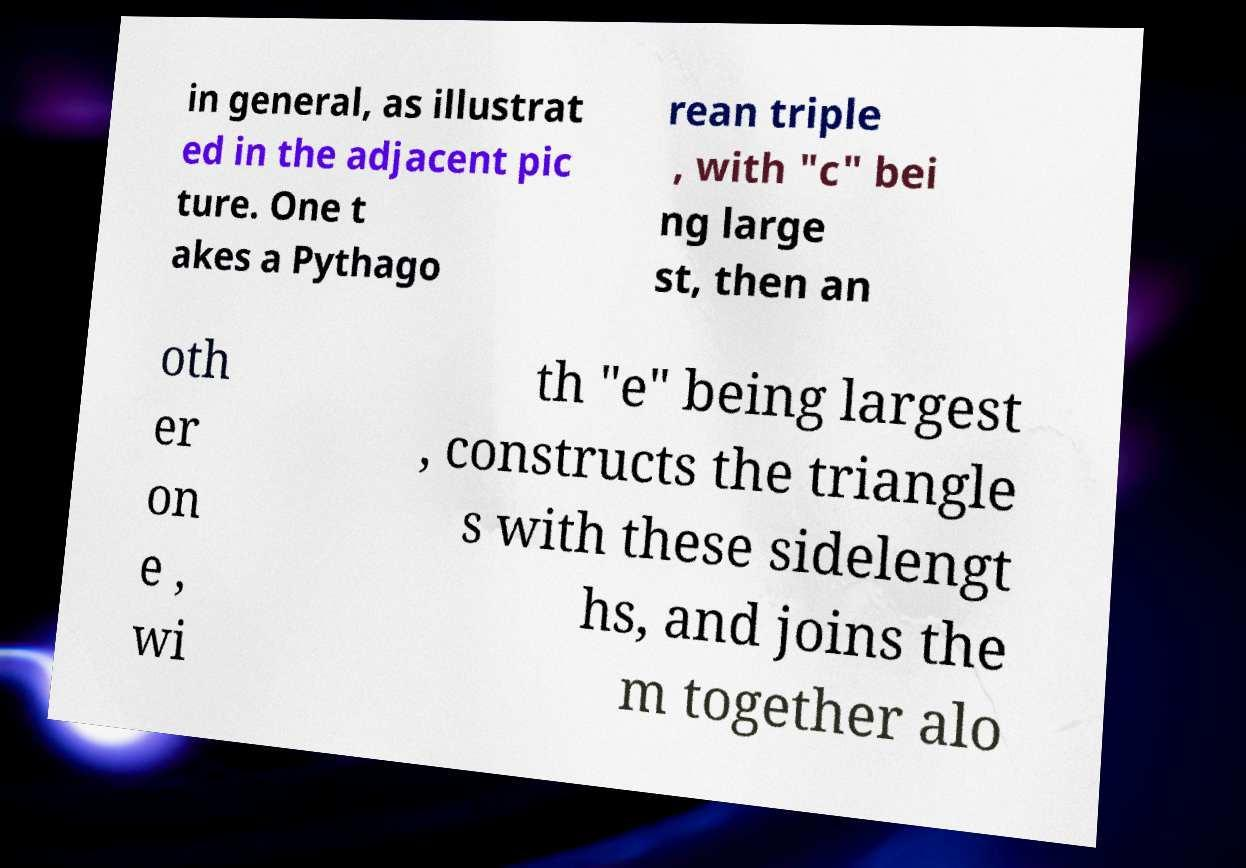What messages or text are displayed in this image? I need them in a readable, typed format. in general, as illustrat ed in the adjacent pic ture. One t akes a Pythago rean triple , with "c" bei ng large st, then an oth er on e , wi th "e" being largest , constructs the triangle s with these sidelengt hs, and joins the m together alo 